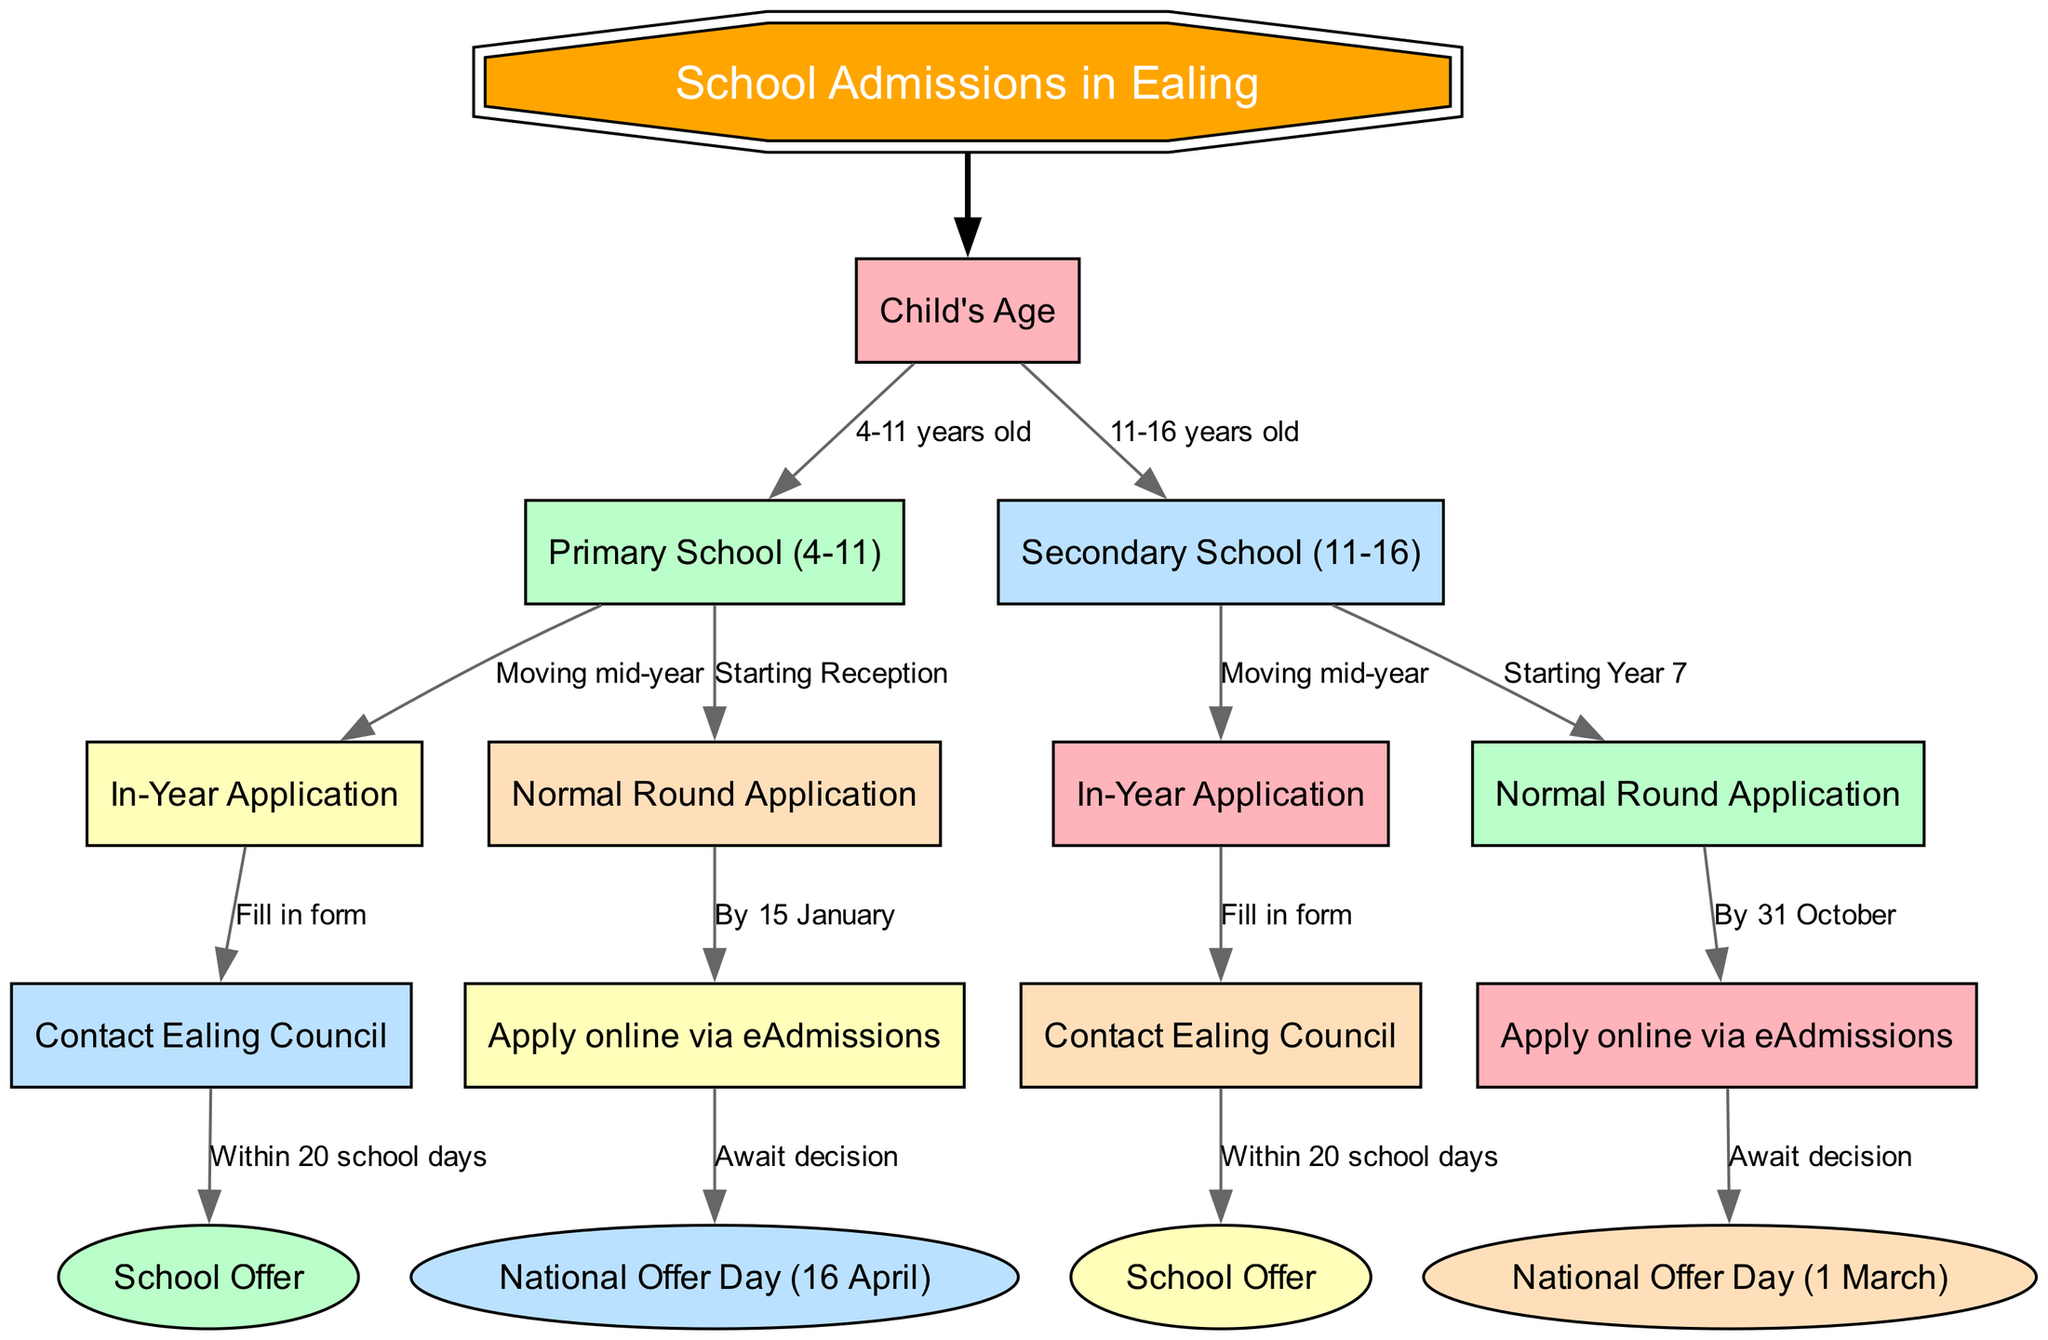What is the root node of the diagram? The diagram's root node is the starting point that introduces the main topic of the diagram, which is "School Admissions in Ealing." Hence, the root node is labeled with this title.
Answer: School Admissions in Ealing How many children does the node for "Child's Age" have? The node for "Child's Age" has two children, specifically indicating the age ranges for school admission, which are "Primary School (4-11)" and "Secondary School (11-16)."
Answer: 2 What is the decision point if the child is starting Reception? If the child is starting Reception, the diagram directs the flow to the node labeled "Normal Round Application," where the next step is to apply online via eAdmissions before the deadline of 15 January.
Answer: Apply online via eAdmissions What step follows after "Contact Ealing Council" for In-Year Applications? After contacting Ealing Council, the next step is to determine the "School Offer," which is the outcome of this action. This indicates finality in the admission process.
Answer: School Offer What is the outcome after applying online via eAdmissions? After applying online via eAdmissions for the Normal Round Application, the flow leads to a specific deadline day when decisions are announced, known as "National Offer Day," which occurs on April 16.
Answer: National Offer Day (16 April) What decision type is made for children moving mid-year in the primary school section? For children moving mid-year in the primary school section, the process involves an In-Year Application, which requires communication with the Ealing Council to ensure the proper steps are followed.
Answer: Contact Ealing Council What is the time frame for the node "Contact Ealing Council" following an In-Year Application? The time frame indicated for communicating with the Ealing Council following an In-Year Application is to receive the "School Offer" within 20 school days from the application.
Answer: Within 20 school days Which node leads to "Await decision" when starting Year 7? The node that leads to the "Await decision" is "Normal Round Application," which is specifically noted for children starting Year 7, suggesting that they must wait for the admissions decision post-application.
Answer: Await decision What actions are to be taken in case of a moving mid-year for Secondary School? In case of moving mid-year for Secondary School, the process starts again with "In-Year Application," which leads to the action of "Contact Ealing Council," maintaining the flow necessary for admission.
Answer: Contact Ealing Council 